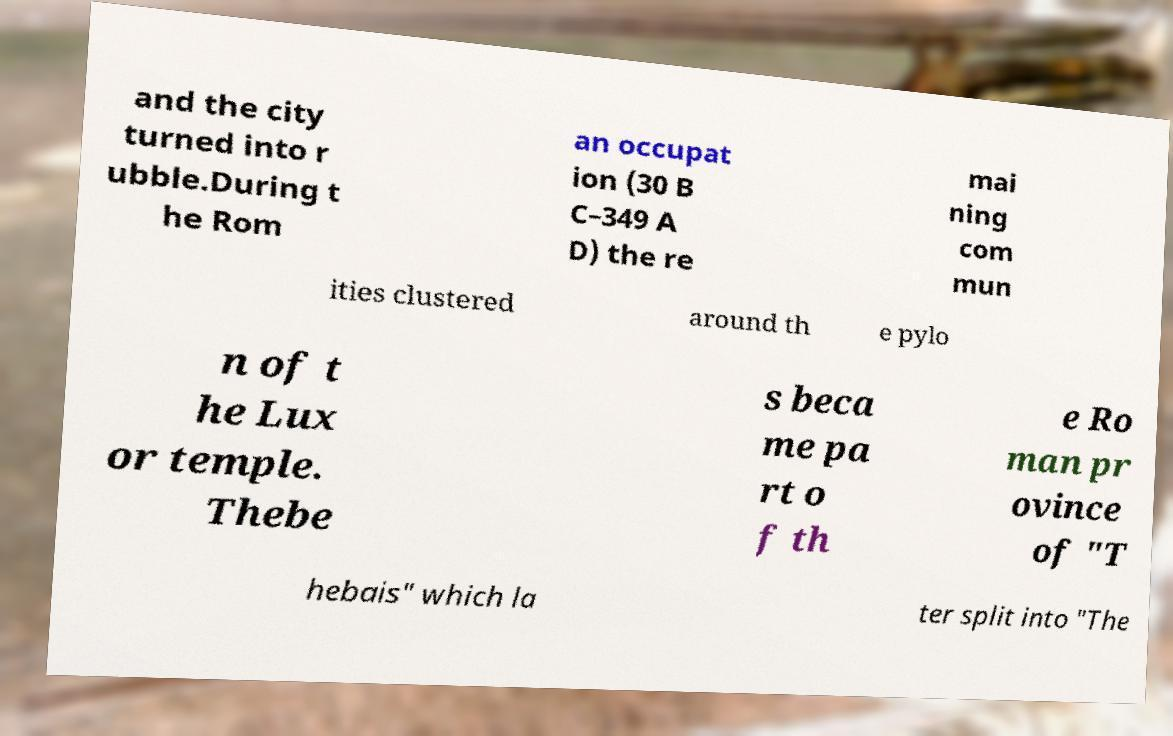Please identify and transcribe the text found in this image. and the city turned into r ubble.During t he Rom an occupat ion (30 B C–349 A D) the re mai ning com mun ities clustered around th e pylo n of t he Lux or temple. Thebe s beca me pa rt o f th e Ro man pr ovince of "T hebais" which la ter split into "The 